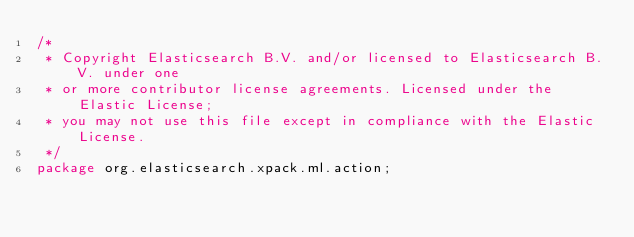<code> <loc_0><loc_0><loc_500><loc_500><_Java_>/*
 * Copyright Elasticsearch B.V. and/or licensed to Elasticsearch B.V. under one
 * or more contributor license agreements. Licensed under the Elastic License;
 * you may not use this file except in compliance with the Elastic License.
 */
package org.elasticsearch.xpack.ml.action;
</code> 